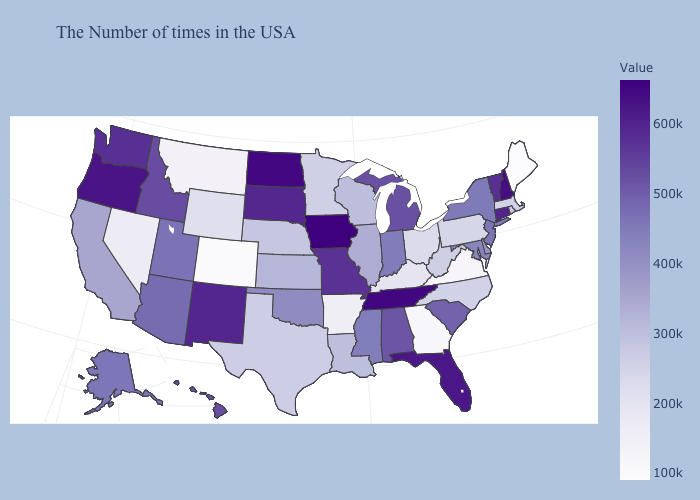Which states have the lowest value in the USA?
Be succinct. Maine. Among the states that border Ohio , does Pennsylvania have the lowest value?
Write a very short answer. No. Among the states that border New Jersey , which have the lowest value?
Be succinct. Pennsylvania. Among the states that border Wisconsin , does Iowa have the highest value?
Quick response, please. Yes. Does Iowa have the lowest value in the USA?
Short answer required. No. 